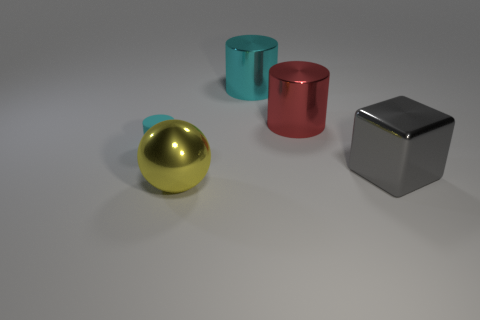Add 3 tiny green metal things. How many objects exist? 8 Subtract all cylinders. How many objects are left? 2 Subtract all rubber things. Subtract all tiny rubber cylinders. How many objects are left? 3 Add 1 big yellow shiny objects. How many big yellow shiny objects are left? 2 Add 1 green balls. How many green balls exist? 1 Subtract 1 red cylinders. How many objects are left? 4 